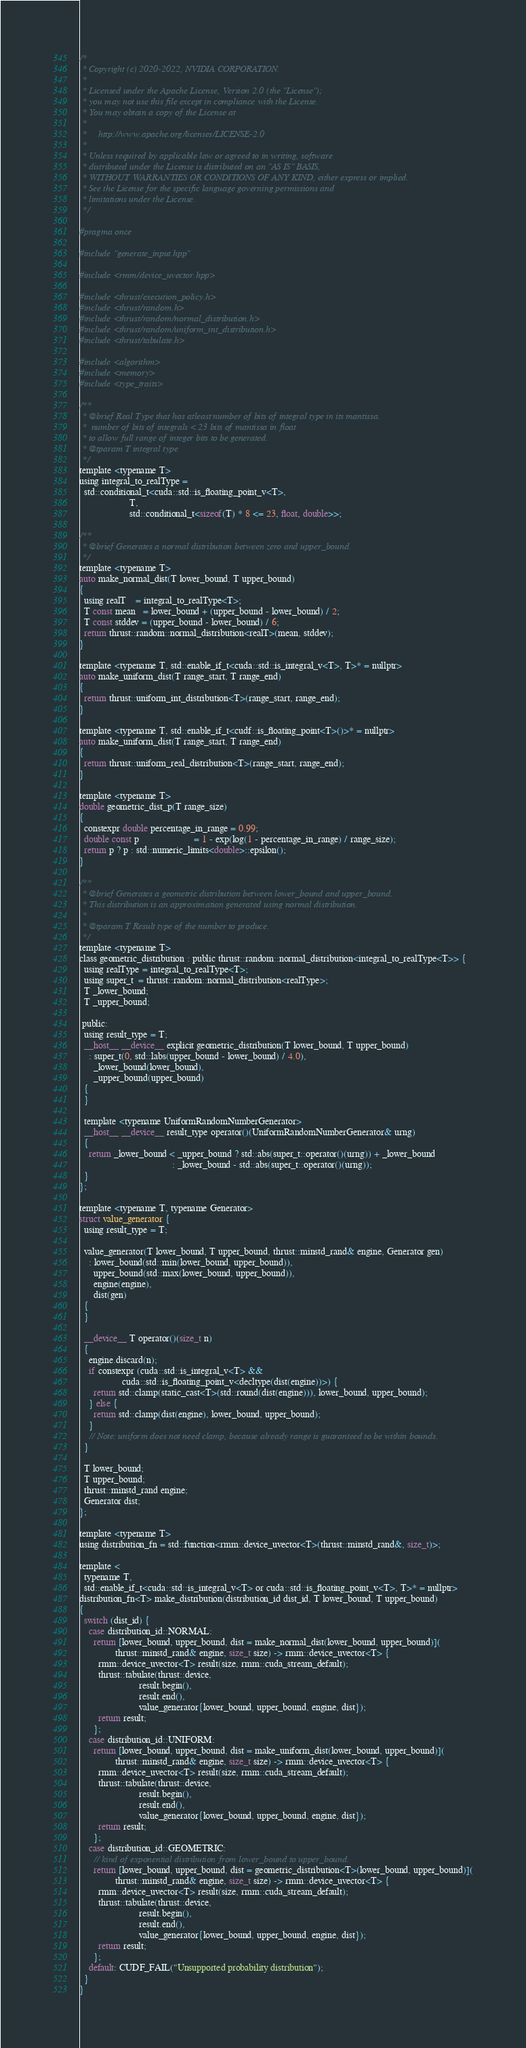Convert code to text. <code><loc_0><loc_0><loc_500><loc_500><_Cuda_>/*
 * Copyright (c) 2020-2022, NVIDIA CORPORATION.
 *
 * Licensed under the Apache License, Version 2.0 (the "License");
 * you may not use this file except in compliance with the License.
 * You may obtain a copy of the License at
 *
 *     http://www.apache.org/licenses/LICENSE-2.0
 *
 * Unless required by applicable law or agreed to in writing, software
 * distributed under the License is distributed on an "AS IS" BASIS,
 * WITHOUT WARRANTIES OR CONDITIONS OF ANY KIND, either express or implied.
 * See the License for the specific language governing permissions and
 * limitations under the License.
 */

#pragma once

#include "generate_input.hpp"

#include <rmm/device_uvector.hpp>

#include <thrust/execution_policy.h>
#include <thrust/random.h>
#include <thrust/random/normal_distribution.h>
#include <thrust/random/uniform_int_distribution.h>
#include <thrust/tabulate.h>

#include <algorithm>
#include <memory>
#include <type_traits>

/**
 * @brief Real Type that has atleast number of bits of integral type in its mantissa.
 *  number of bits of integrals < 23 bits of mantissa in float
 * to allow full range of integer bits to be generated.
 * @tparam T integral type
 */
template <typename T>
using integral_to_realType =
  std::conditional_t<cuda::std::is_floating_point_v<T>,
                     T,
                     std::conditional_t<sizeof(T) * 8 <= 23, float, double>>;

/**
 * @brief Generates a normal distribution between zero and upper_bound.
 */
template <typename T>
auto make_normal_dist(T lower_bound, T upper_bound)
{
  using realT    = integral_to_realType<T>;
  T const mean   = lower_bound + (upper_bound - lower_bound) / 2;
  T const stddev = (upper_bound - lower_bound) / 6;
  return thrust::random::normal_distribution<realT>(mean, stddev);
}

template <typename T, std::enable_if_t<cuda::std::is_integral_v<T>, T>* = nullptr>
auto make_uniform_dist(T range_start, T range_end)
{
  return thrust::uniform_int_distribution<T>(range_start, range_end);
}

template <typename T, std::enable_if_t<cudf::is_floating_point<T>()>* = nullptr>
auto make_uniform_dist(T range_start, T range_end)
{
  return thrust::uniform_real_distribution<T>(range_start, range_end);
}

template <typename T>
double geometric_dist_p(T range_size)
{
  constexpr double percentage_in_range = 0.99;
  double const p                       = 1 - exp(log(1 - percentage_in_range) / range_size);
  return p ? p : std::numeric_limits<double>::epsilon();
}

/**
 * @brief Generates a geometric distribution between lower_bound and upper_bound.
 * This distribution is an approximation generated using normal distribution.
 *
 * @tparam T Result type of the number to produce.
 */
template <typename T>
class geometric_distribution : public thrust::random::normal_distribution<integral_to_realType<T>> {
  using realType = integral_to_realType<T>;
  using super_t  = thrust::random::normal_distribution<realType>;
  T _lower_bound;
  T _upper_bound;

 public:
  using result_type = T;
  __host__ __device__ explicit geometric_distribution(T lower_bound, T upper_bound)
    : super_t(0, std::labs(upper_bound - lower_bound) / 4.0),
      _lower_bound(lower_bound),
      _upper_bound(upper_bound)
  {
  }

  template <typename UniformRandomNumberGenerator>
  __host__ __device__ result_type operator()(UniformRandomNumberGenerator& urng)
  {
    return _lower_bound < _upper_bound ? std::abs(super_t::operator()(urng)) + _lower_bound
                                       : _lower_bound - std::abs(super_t::operator()(urng));
  }
};

template <typename T, typename Generator>
struct value_generator {
  using result_type = T;

  value_generator(T lower_bound, T upper_bound, thrust::minstd_rand& engine, Generator gen)
    : lower_bound(std::min(lower_bound, upper_bound)),
      upper_bound(std::max(lower_bound, upper_bound)),
      engine(engine),
      dist(gen)
  {
  }

  __device__ T operator()(size_t n)
  {
    engine.discard(n);
    if constexpr (cuda::std::is_integral_v<T> &&
                  cuda::std::is_floating_point_v<decltype(dist(engine))>) {
      return std::clamp(static_cast<T>(std::round(dist(engine))), lower_bound, upper_bound);
    } else {
      return std::clamp(dist(engine), lower_bound, upper_bound);
    }
    // Note: uniform does not need clamp, because already range is guaranteed to be within bounds.
  }

  T lower_bound;
  T upper_bound;
  thrust::minstd_rand engine;
  Generator dist;
};

template <typename T>
using distribution_fn = std::function<rmm::device_uvector<T>(thrust::minstd_rand&, size_t)>;

template <
  typename T,
  std::enable_if_t<cuda::std::is_integral_v<T> or cuda::std::is_floating_point_v<T>, T>* = nullptr>
distribution_fn<T> make_distribution(distribution_id dist_id, T lower_bound, T upper_bound)
{
  switch (dist_id) {
    case distribution_id::NORMAL:
      return [lower_bound, upper_bound, dist = make_normal_dist(lower_bound, upper_bound)](
               thrust::minstd_rand& engine, size_t size) -> rmm::device_uvector<T> {
        rmm::device_uvector<T> result(size, rmm::cuda_stream_default);
        thrust::tabulate(thrust::device,
                         result.begin(),
                         result.end(),
                         value_generator{lower_bound, upper_bound, engine, dist});
        return result;
      };
    case distribution_id::UNIFORM:
      return [lower_bound, upper_bound, dist = make_uniform_dist(lower_bound, upper_bound)](
               thrust::minstd_rand& engine, size_t size) -> rmm::device_uvector<T> {
        rmm::device_uvector<T> result(size, rmm::cuda_stream_default);
        thrust::tabulate(thrust::device,
                         result.begin(),
                         result.end(),
                         value_generator{lower_bound, upper_bound, engine, dist});
        return result;
      };
    case distribution_id::GEOMETRIC:
      // kind of exponential distribution from lower_bound to upper_bound.
      return [lower_bound, upper_bound, dist = geometric_distribution<T>(lower_bound, upper_bound)](
               thrust::minstd_rand& engine, size_t size) -> rmm::device_uvector<T> {
        rmm::device_uvector<T> result(size, rmm::cuda_stream_default);
        thrust::tabulate(thrust::device,
                         result.begin(),
                         result.end(),
                         value_generator{lower_bound, upper_bound, engine, dist});
        return result;
      };
    default: CUDF_FAIL("Unsupported probability distribution");
  }
}
</code> 